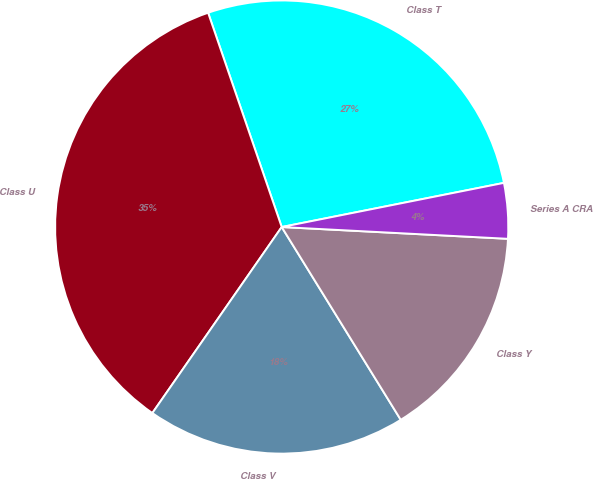Convert chart to OTSL. <chart><loc_0><loc_0><loc_500><loc_500><pie_chart><fcel>Class T<fcel>Class U<fcel>Class V<fcel>Class Y<fcel>Series A CRA<nl><fcel>27.15%<fcel>35.07%<fcel>18.48%<fcel>15.37%<fcel>3.95%<nl></chart> 